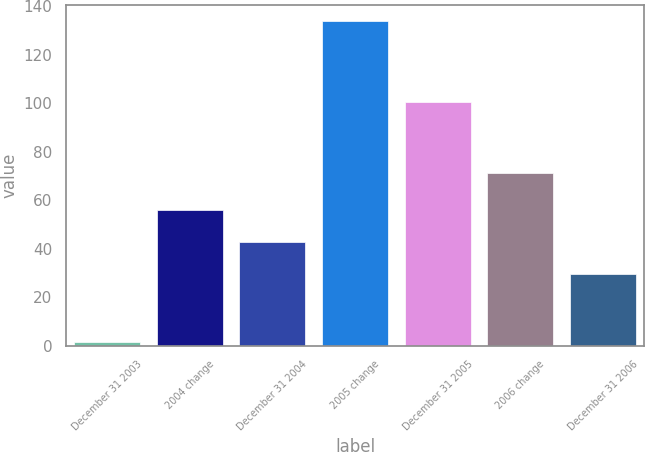Convert chart. <chart><loc_0><loc_0><loc_500><loc_500><bar_chart><fcel>December 31 2003<fcel>2004 change<fcel>December 31 2004<fcel>2005 change<fcel>December 31 2005<fcel>2006 change<fcel>December 31 2006<nl><fcel>1.4<fcel>56<fcel>42.75<fcel>133.9<fcel>100.7<fcel>71.2<fcel>29.5<nl></chart> 